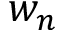Convert formula to latex. <formula><loc_0><loc_0><loc_500><loc_500>w _ { n }</formula> 